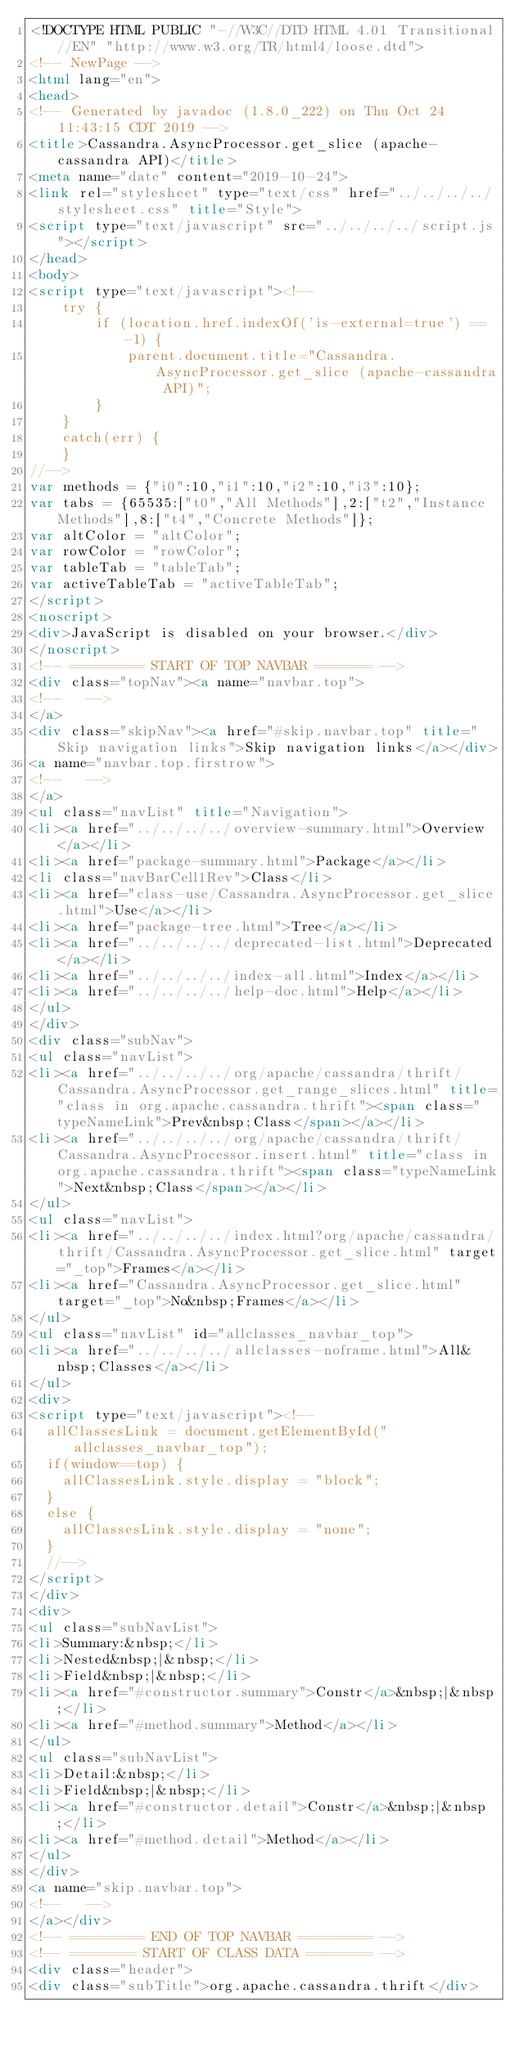Convert code to text. <code><loc_0><loc_0><loc_500><loc_500><_HTML_><!DOCTYPE HTML PUBLIC "-//W3C//DTD HTML 4.01 Transitional//EN" "http://www.w3.org/TR/html4/loose.dtd">
<!-- NewPage -->
<html lang="en">
<head>
<!-- Generated by javadoc (1.8.0_222) on Thu Oct 24 11:43:15 CDT 2019 -->
<title>Cassandra.AsyncProcessor.get_slice (apache-cassandra API)</title>
<meta name="date" content="2019-10-24">
<link rel="stylesheet" type="text/css" href="../../../../stylesheet.css" title="Style">
<script type="text/javascript" src="../../../../script.js"></script>
</head>
<body>
<script type="text/javascript"><!--
    try {
        if (location.href.indexOf('is-external=true') == -1) {
            parent.document.title="Cassandra.AsyncProcessor.get_slice (apache-cassandra API)";
        }
    }
    catch(err) {
    }
//-->
var methods = {"i0":10,"i1":10,"i2":10,"i3":10};
var tabs = {65535:["t0","All Methods"],2:["t2","Instance Methods"],8:["t4","Concrete Methods"]};
var altColor = "altColor";
var rowColor = "rowColor";
var tableTab = "tableTab";
var activeTableTab = "activeTableTab";
</script>
<noscript>
<div>JavaScript is disabled on your browser.</div>
</noscript>
<!-- ========= START OF TOP NAVBAR ======= -->
<div class="topNav"><a name="navbar.top">
<!--   -->
</a>
<div class="skipNav"><a href="#skip.navbar.top" title="Skip navigation links">Skip navigation links</a></div>
<a name="navbar.top.firstrow">
<!--   -->
</a>
<ul class="navList" title="Navigation">
<li><a href="../../../../overview-summary.html">Overview</a></li>
<li><a href="package-summary.html">Package</a></li>
<li class="navBarCell1Rev">Class</li>
<li><a href="class-use/Cassandra.AsyncProcessor.get_slice.html">Use</a></li>
<li><a href="package-tree.html">Tree</a></li>
<li><a href="../../../../deprecated-list.html">Deprecated</a></li>
<li><a href="../../../../index-all.html">Index</a></li>
<li><a href="../../../../help-doc.html">Help</a></li>
</ul>
</div>
<div class="subNav">
<ul class="navList">
<li><a href="../../../../org/apache/cassandra/thrift/Cassandra.AsyncProcessor.get_range_slices.html" title="class in org.apache.cassandra.thrift"><span class="typeNameLink">Prev&nbsp;Class</span></a></li>
<li><a href="../../../../org/apache/cassandra/thrift/Cassandra.AsyncProcessor.insert.html" title="class in org.apache.cassandra.thrift"><span class="typeNameLink">Next&nbsp;Class</span></a></li>
</ul>
<ul class="navList">
<li><a href="../../../../index.html?org/apache/cassandra/thrift/Cassandra.AsyncProcessor.get_slice.html" target="_top">Frames</a></li>
<li><a href="Cassandra.AsyncProcessor.get_slice.html" target="_top">No&nbsp;Frames</a></li>
</ul>
<ul class="navList" id="allclasses_navbar_top">
<li><a href="../../../../allclasses-noframe.html">All&nbsp;Classes</a></li>
</ul>
<div>
<script type="text/javascript"><!--
  allClassesLink = document.getElementById("allclasses_navbar_top");
  if(window==top) {
    allClassesLink.style.display = "block";
  }
  else {
    allClassesLink.style.display = "none";
  }
  //-->
</script>
</div>
<div>
<ul class="subNavList">
<li>Summary:&nbsp;</li>
<li>Nested&nbsp;|&nbsp;</li>
<li>Field&nbsp;|&nbsp;</li>
<li><a href="#constructor.summary">Constr</a>&nbsp;|&nbsp;</li>
<li><a href="#method.summary">Method</a></li>
</ul>
<ul class="subNavList">
<li>Detail:&nbsp;</li>
<li>Field&nbsp;|&nbsp;</li>
<li><a href="#constructor.detail">Constr</a>&nbsp;|&nbsp;</li>
<li><a href="#method.detail">Method</a></li>
</ul>
</div>
<a name="skip.navbar.top">
<!--   -->
</a></div>
<!-- ========= END OF TOP NAVBAR ========= -->
<!-- ======== START OF CLASS DATA ======== -->
<div class="header">
<div class="subTitle">org.apache.cassandra.thrift</div></code> 